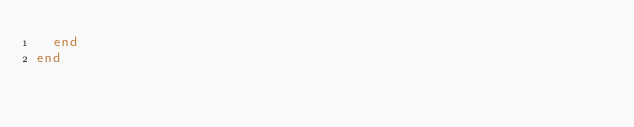Convert code to text. <code><loc_0><loc_0><loc_500><loc_500><_Crystal_>  end
end
</code> 